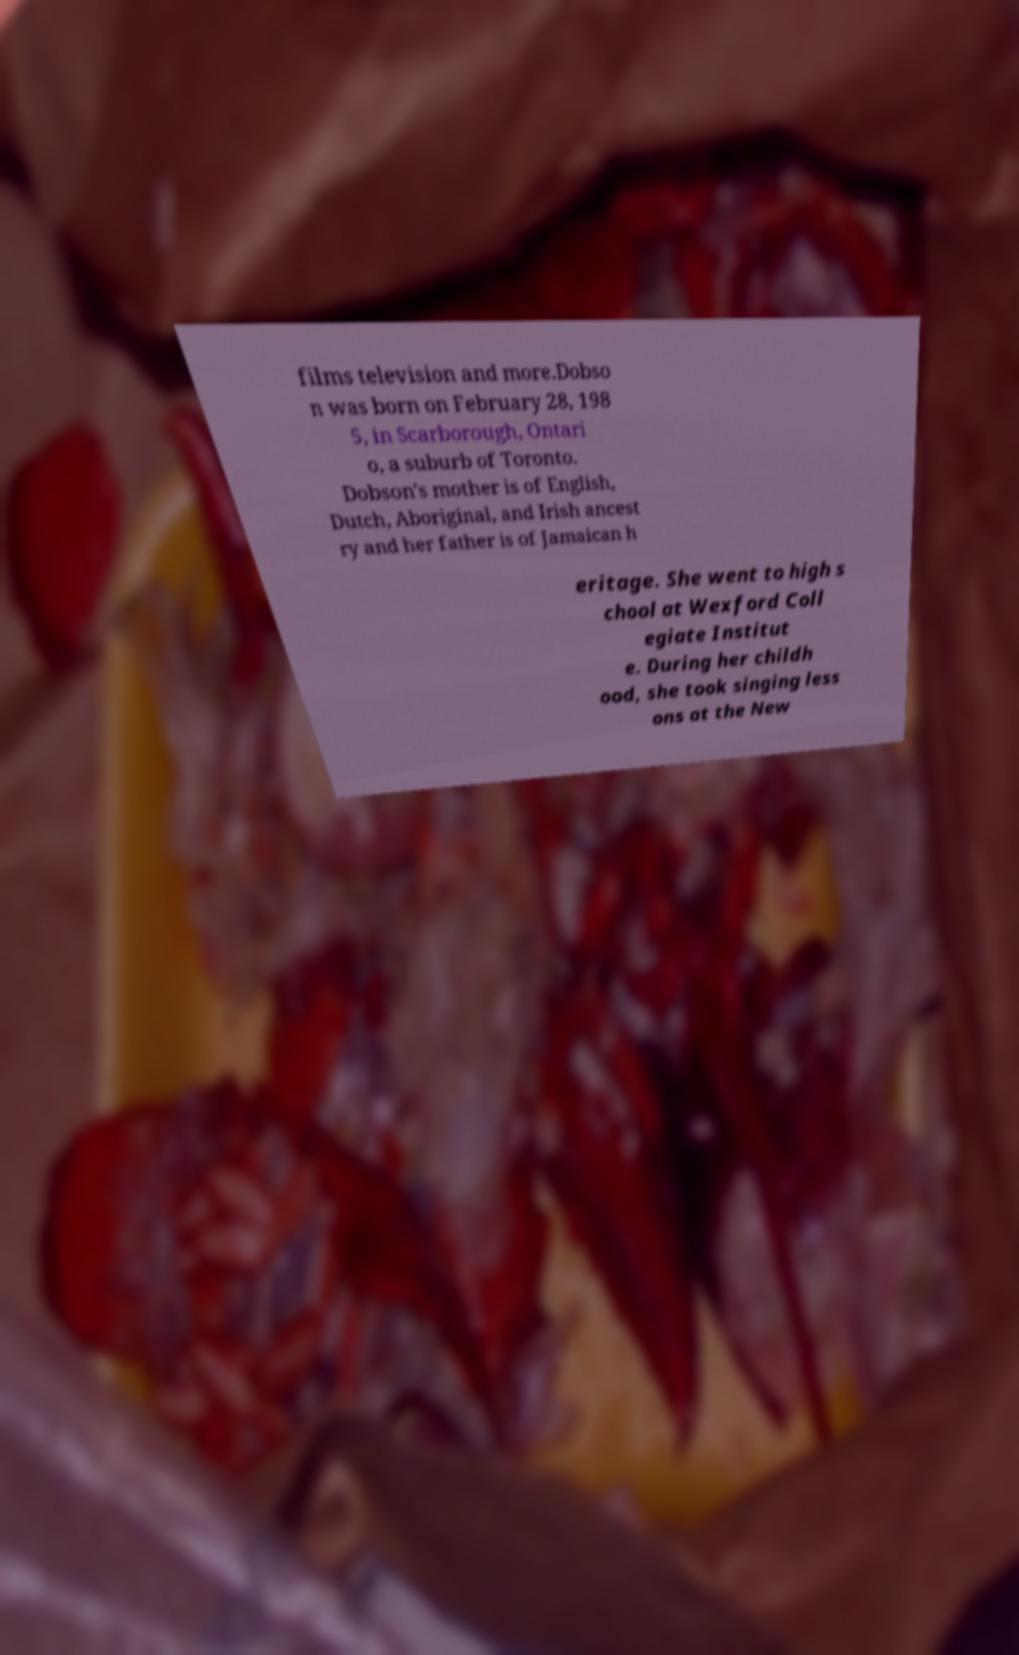There's text embedded in this image that I need extracted. Can you transcribe it verbatim? films television and more.Dobso n was born on February 28, 198 5, in Scarborough, Ontari o, a suburb of Toronto. Dobson's mother is of English, Dutch, Aboriginal, and Irish ancest ry and her father is of Jamaican h eritage. She went to high s chool at Wexford Coll egiate Institut e. During her childh ood, she took singing less ons at the New 